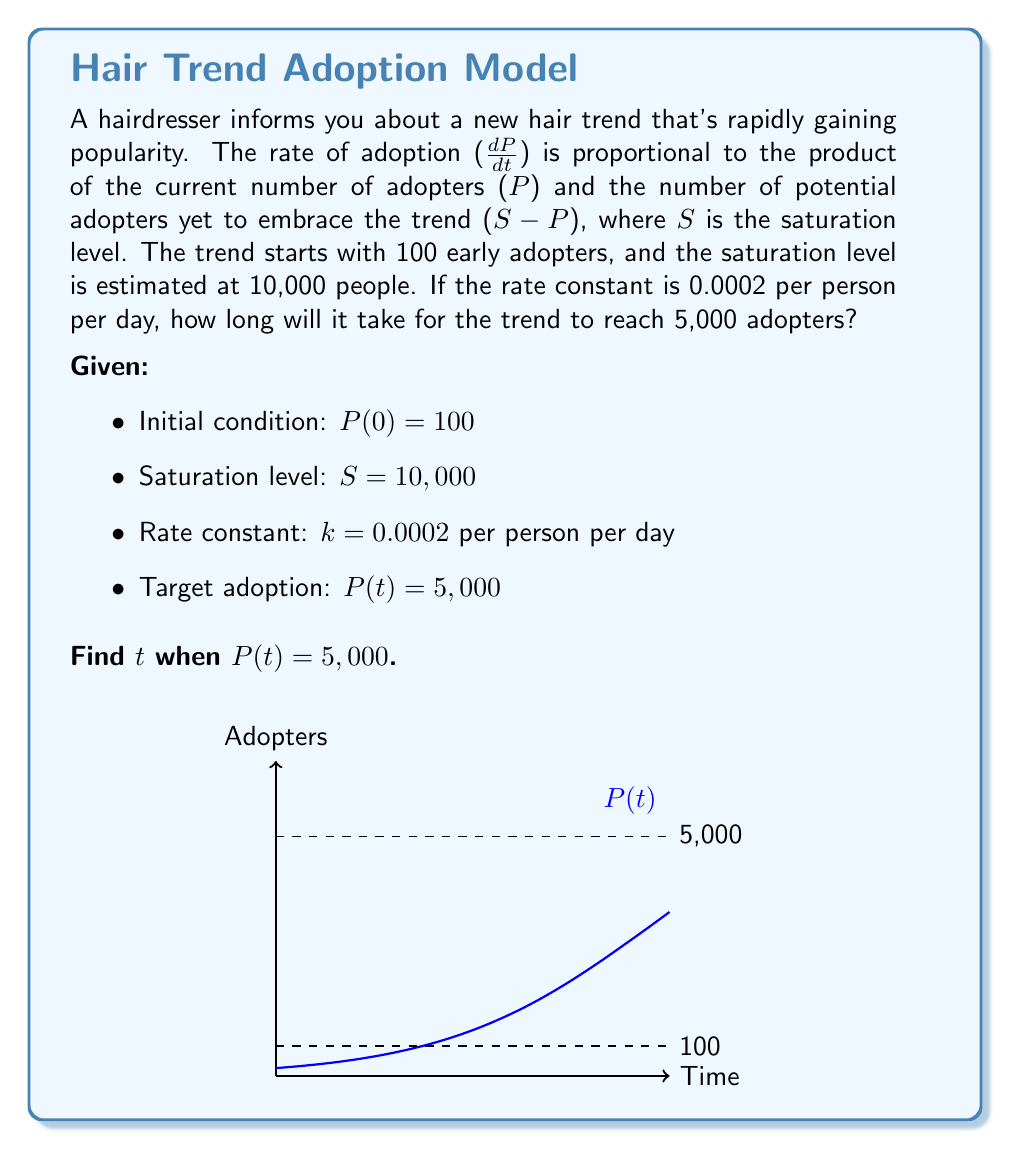Give your solution to this math problem. Let's solve this problem step by step using the logistic growth model:

1) The differential equation for this model is:
   $$\frac{dP}{dt} = kP(S-P)$$

2) The solution to this equation is the logistic function:
   $$P(t) = \frac{S}{1 + Ae^{-kSt}}$$
   where $A$ is a constant determined by the initial condition.

3) Using the initial condition $P(0) = 100$, we can find $A$:
   $$100 = \frac{10000}{1 + A}$$
   $$A = 99$$

4) Now our specific logistic function is:
   $$P(t) = \frac{10000}{1 + 99e^{-0.0002 \cdot 10000t}}$$

5) We want to find $t$ when $P(t) = 5000$. Let's substitute this:
   $$5000 = \frac{10000}{1 + 99e^{-2t}}$$

6) Solve for $t$:
   $$1 + 99e^{-2t} = 2$$
   $$99e^{-2t} = 1$$
   $$e^{-2t} = \frac{1}{99}$$
   $$-2t = \ln(\frac{1}{99})$$
   $$t = -\frac{1}{2}\ln(\frac{1}{99}) = \frac{1}{2}\ln(99)$$

7) Calculate the final value:
   $$t = \frac{1}{2}\ln(99) \approx 2.296$$

Therefore, it will take approximately 2.296 days for the hair trend to reach 5,000 adopters.
Answer: 2.296 days 